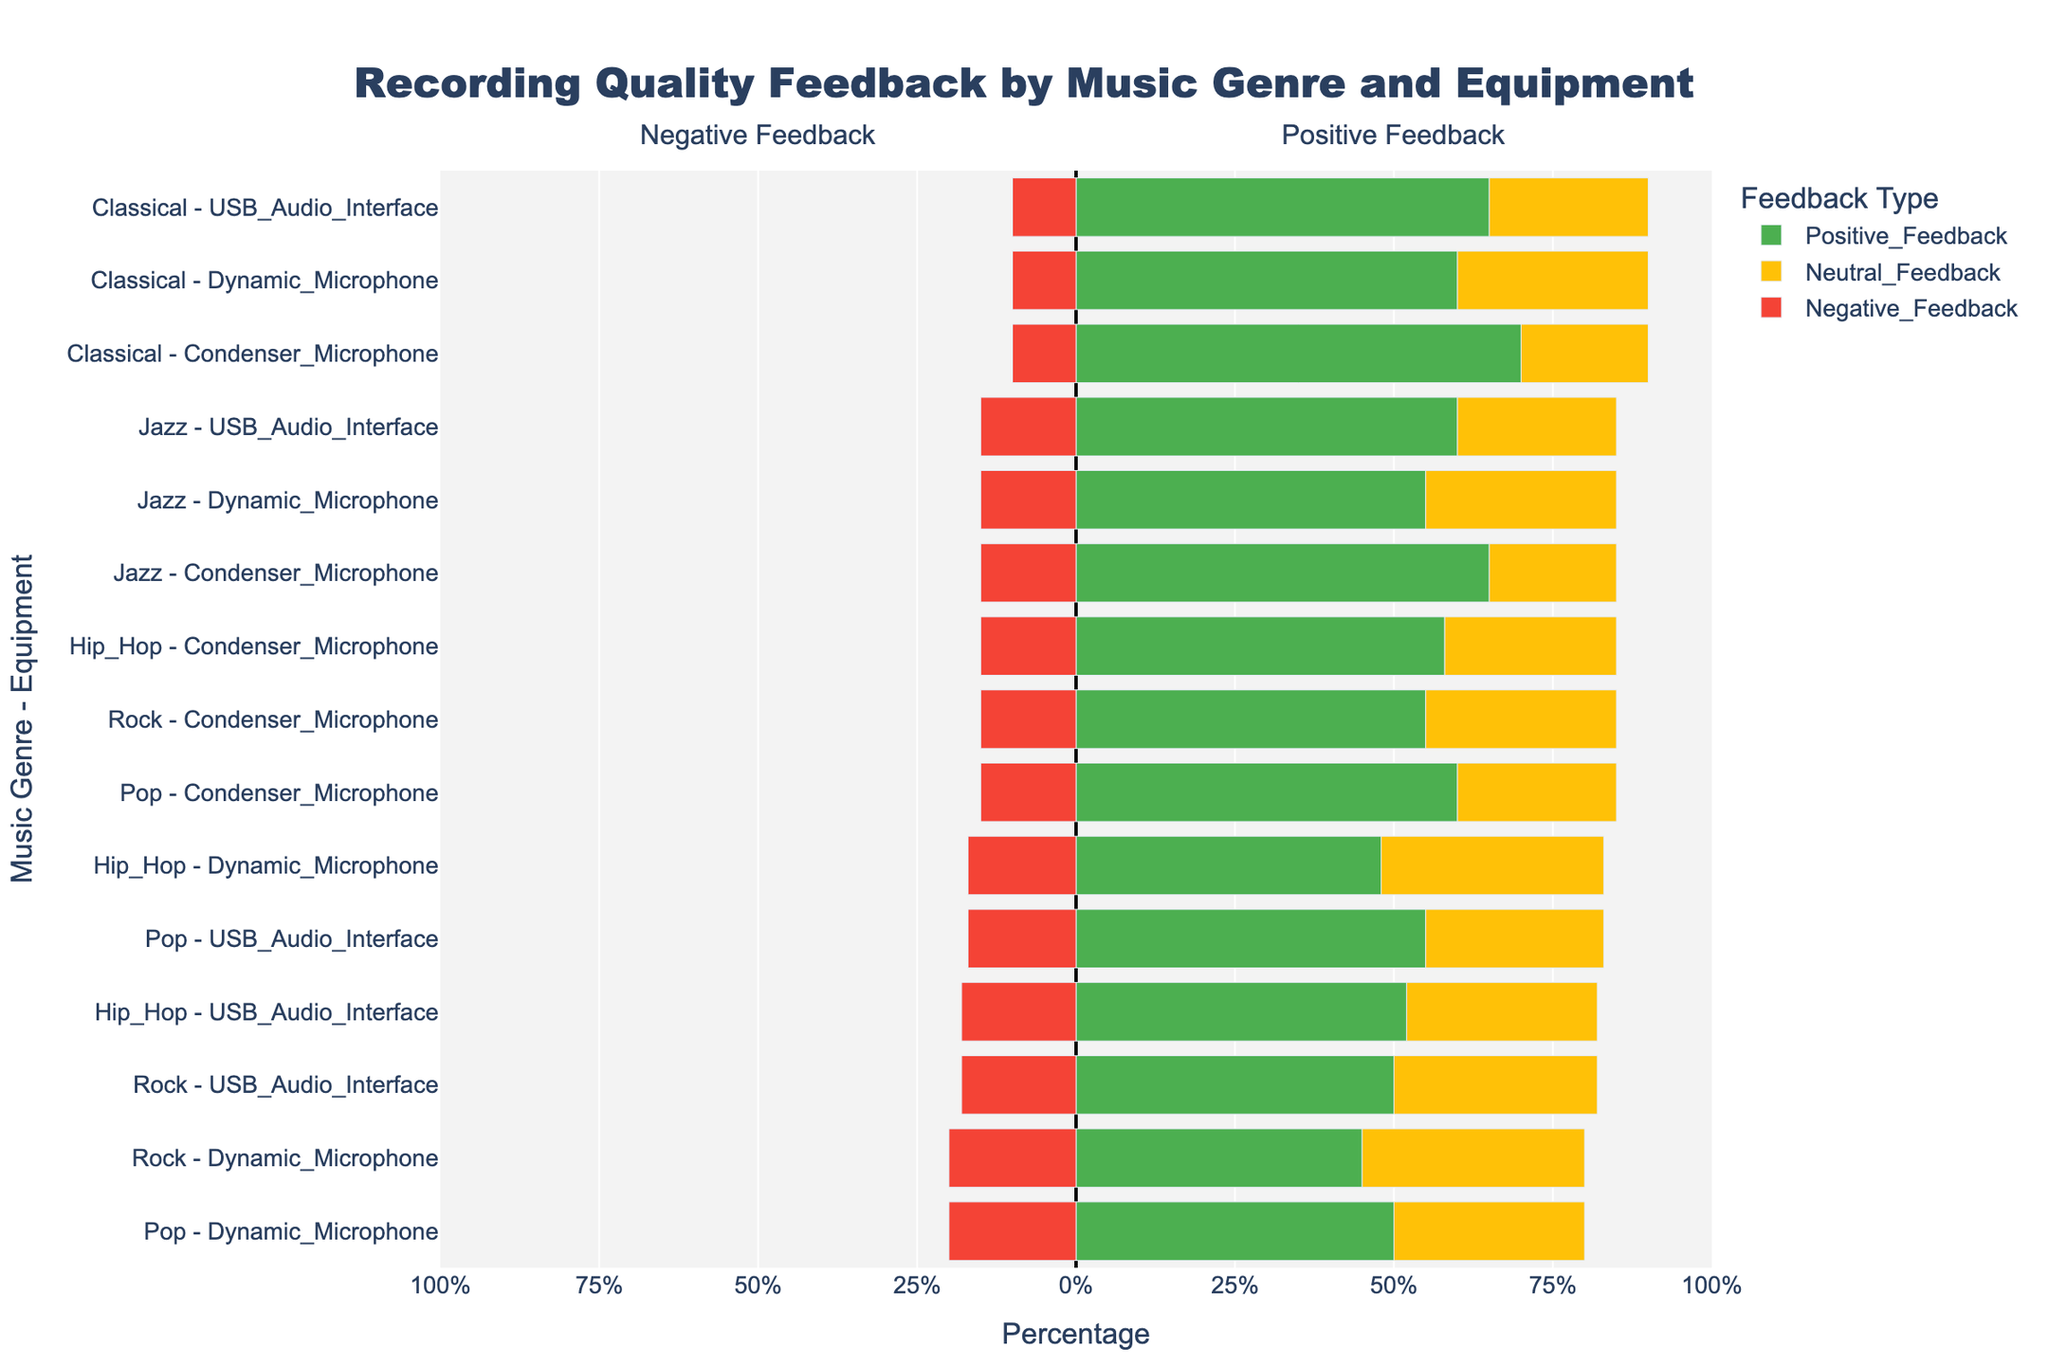Which equipment used with Pop music received the highest positive feedback? For Pop music, check the Positive Feedback percentages for Condenser Microphone (60%), Dynamic Microphone (50%), and USB Audio Interface (55%). The highest positive feedback is 60% for Condenser Microphone.
Answer: Condenser Microphone How does the negative feedback for Rock music recorded with Dynamic Microphone compare to that of Classical music recorded with USB Audio Interface? Compare the Negative Feedback percentages: Rock - Dynamic Microphone (20%) and Classical - USB Audio Interface (10%). The negative feedback for Rock - Dynamic Microphone is higher.
Answer: Higher Among the genres listed, which received the highest positive feedback for recordings made with a USB Audio Interface? Check Positive Feedback percentages for USB Audio Interface across genres: Pop (55%), Rock (50%), Hip Hop (52%), Jazz (60%), Classical (65%). The highest is 65% for Classical.
Answer: Classical What is the total neutral feedback percentage for the combinations of Jazz-USB Audio Interface and Hip Hop-Dynamic Microphone? Summarize the Neutral Feedback percentages: Jazz - USB Audio Interface (25%) and Hip Hop - Dynamic Microphone (35%). The total is 25% + 35% = 60%.
Answer: 60% Which combination has the smallest negative feedback, and what is its value? Identify the smallest Negative Feedback percentage across all combinations. Most values are 15% and 10%, but the smallest is Classical - Condenser Microphone, Dynamic Microphone, and USB Audio Interface with 10%.
Answer: Classical with any equipment (10%) Is there any genre where the positive feedback with Condenser Microphones is less than that with Dynamic Microphones? Compare Positive Feedback percentages for Condenser and Dynamic Mics in each genre: Pop (60% vs 50%), Rock (55% vs 45%), Hip Hop (58% vs 48%), Jazz (65% vs 55%), Classical (70% vs 60%). There is no such genre.
Answer: No Which genre and equipment combination received the highest mixture of neutral and negative feedback percentages? Add Neutral and Negative Feedback percentages for all combinations. Check the highest sum: Pop-Condenser (25+15=40), Dynamic (30+20=50), USB (28+17=45), Rock-Condenser (30+15=45), Dynamic (35+20=55), USB (32+18=50), Hip Hop-Condenser (27+15=42), Dynamic (35+17=52), USB (30+18=48), Jazz-Condenser (20+15=35), Dynamic (30+15=45), USB (25+15=40), Classical-Condenser (20+10=30), Dynamic (30+10=40), USB (25+10=35). Rock - Dynamic has the highest mixture with 55%.
Answer: Rock - Dynamic Microphone (55%) 